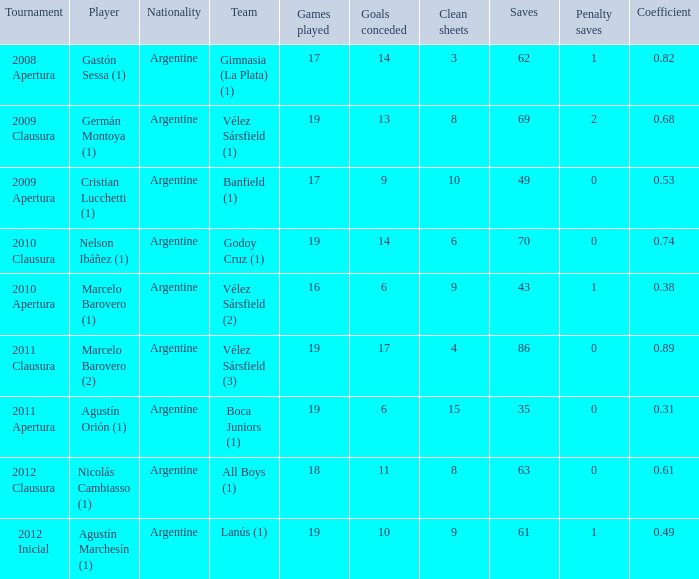How many nationalities are there for the 2011 apertura? 1.0. 